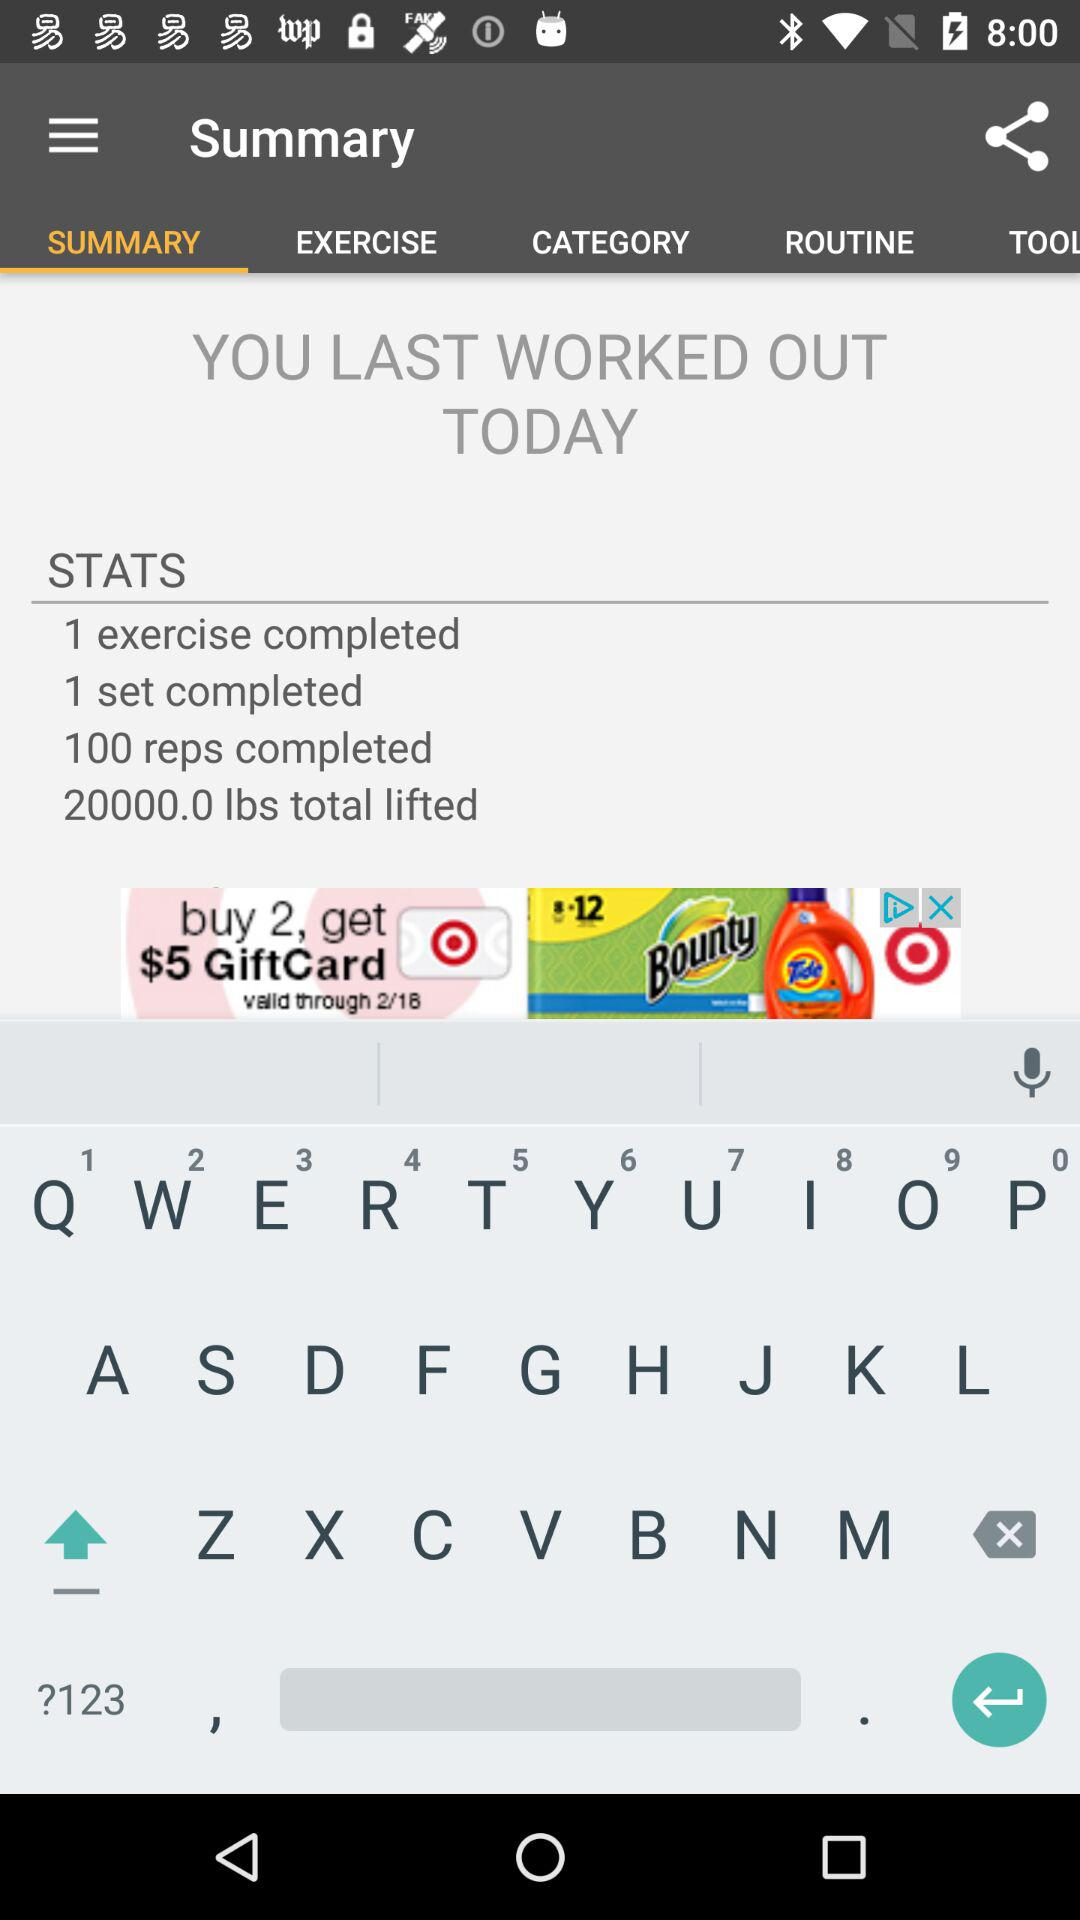How many reps did you complete? 100 